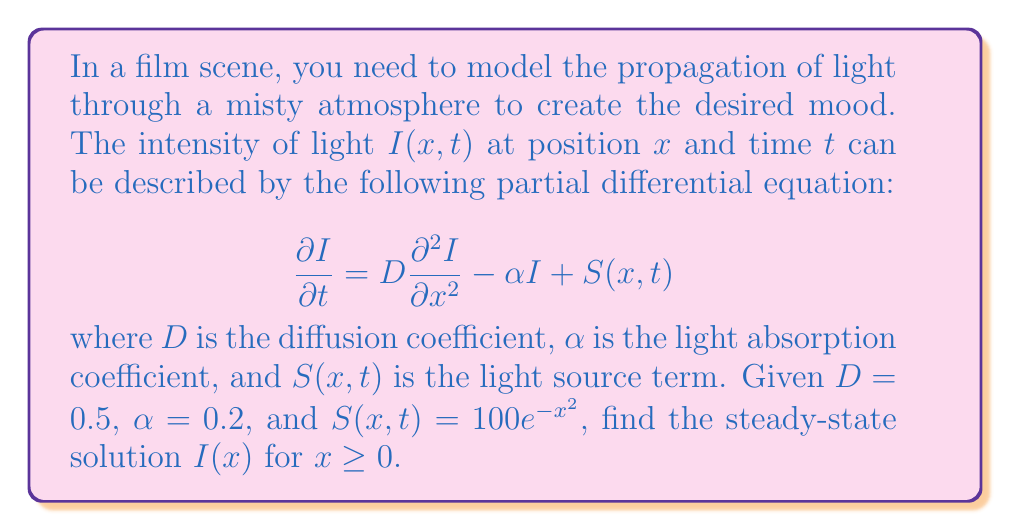Provide a solution to this math problem. To find the steady-state solution, we follow these steps:

1) In steady-state, the intensity doesn't change with time, so $\frac{\partial I}{\partial t} = 0$. Our equation becomes:

   $$0 = D \frac{d^2 I}{dx^2} - \alpha I + S(x)$$

2) Substituting the given values:

   $$0 = 0.5 \frac{d^2 I}{dx^2} - 0.2 I + 100e^{-x^2}$$

3) Rearranging:

   $$0.5 \frac{d^2 I}{dx^2} - 0.2 I = -100e^{-x^2}$$

4) This is a non-homogeneous second-order ODE. The general solution is the sum of the homogeneous solution and a particular solution.

5) For the homogeneous part $0.5 \frac{d^2 I}{dx^2} - 0.2 I = 0$, we assume $I = e^{rx}$:

   $$0.5r^2 - 0.2 = 0$$
   $$r^2 = 0.4$$
   $$r = \pm \sqrt{0.4} = \pm \frac{2}{\sqrt{5}}$$

   So the homogeneous solution is $I_h = Ae^{\frac{2x}{\sqrt{5}}} + Be^{-\frac{2x}{\sqrt{5}}}$

6) For the particular solution, we assume $I_p = Ce^{-x^2}$:

   $$0.5(4x^2C - 2C)e^{-x^2} - 0.2Ce^{-x^2} = -100e^{-x^2}$$
   $$(2x^2C - C - 0.2C)e^{-x^2} = -100e^{-x^2}$$
   $$2x^2C - 1.2C = -100$$

   This should hold for all $x$, so $C = 100$

7) The general solution is:

   $$I(x) = Ae^{\frac{2x}{\sqrt{5}}} + Be^{-\frac{2x}{\sqrt{5}}} + 100e^{-x^2}$$

8) For $x \geq 0$, we need $I(x)$ to remain bounded as $x \to \infty$, so $A = 0$.

9) The final solution is:

   $$I(x) = Be^{-\frac{2x}{\sqrt{5}}} + 100e^{-x^2}$$

   where $B$ can be determined by the boundary condition at $x = 0$.
Answer: $I(x) = Be^{-\frac{2x}{\sqrt{5}}} + 100e^{-x^2}$, $x \geq 0$ 